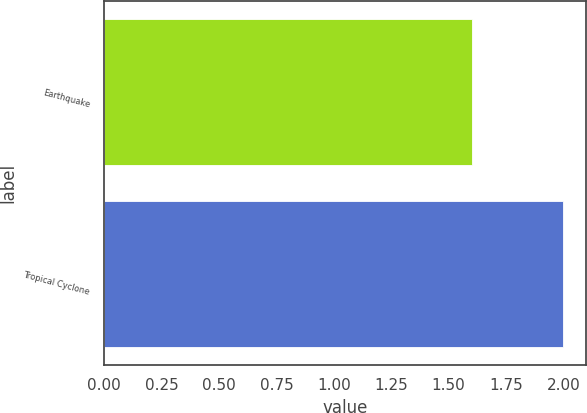<chart> <loc_0><loc_0><loc_500><loc_500><bar_chart><fcel>Earthquake<fcel>Tropical Cyclone<nl><fcel>1.6<fcel>2<nl></chart> 